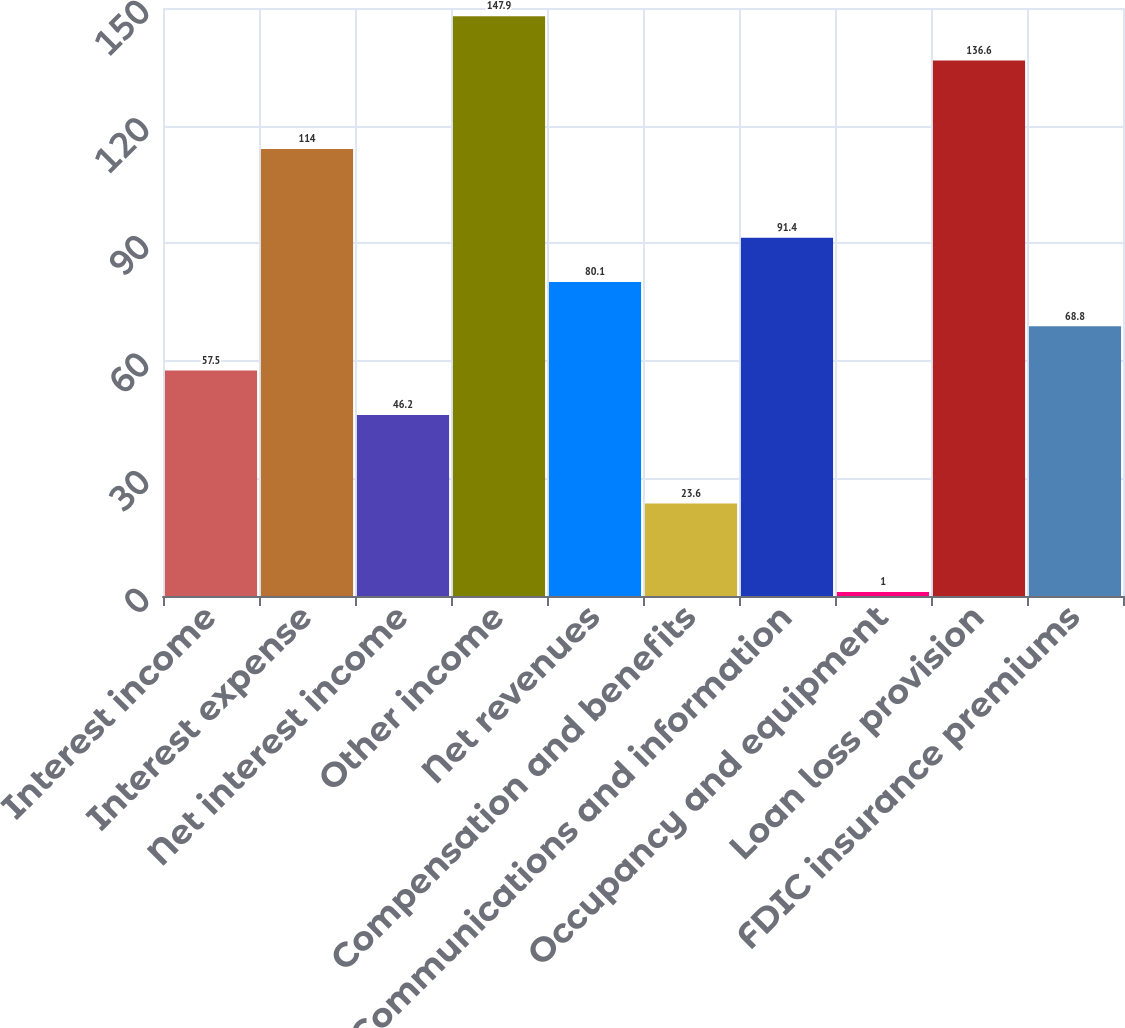Convert chart to OTSL. <chart><loc_0><loc_0><loc_500><loc_500><bar_chart><fcel>Interest income<fcel>Interest expense<fcel>Net interest income<fcel>Other income<fcel>Net revenues<fcel>Compensation and benefits<fcel>Communications and information<fcel>Occupancy and equipment<fcel>Loan loss provision<fcel>FDIC insurance premiums<nl><fcel>57.5<fcel>114<fcel>46.2<fcel>147.9<fcel>80.1<fcel>23.6<fcel>91.4<fcel>1<fcel>136.6<fcel>68.8<nl></chart> 